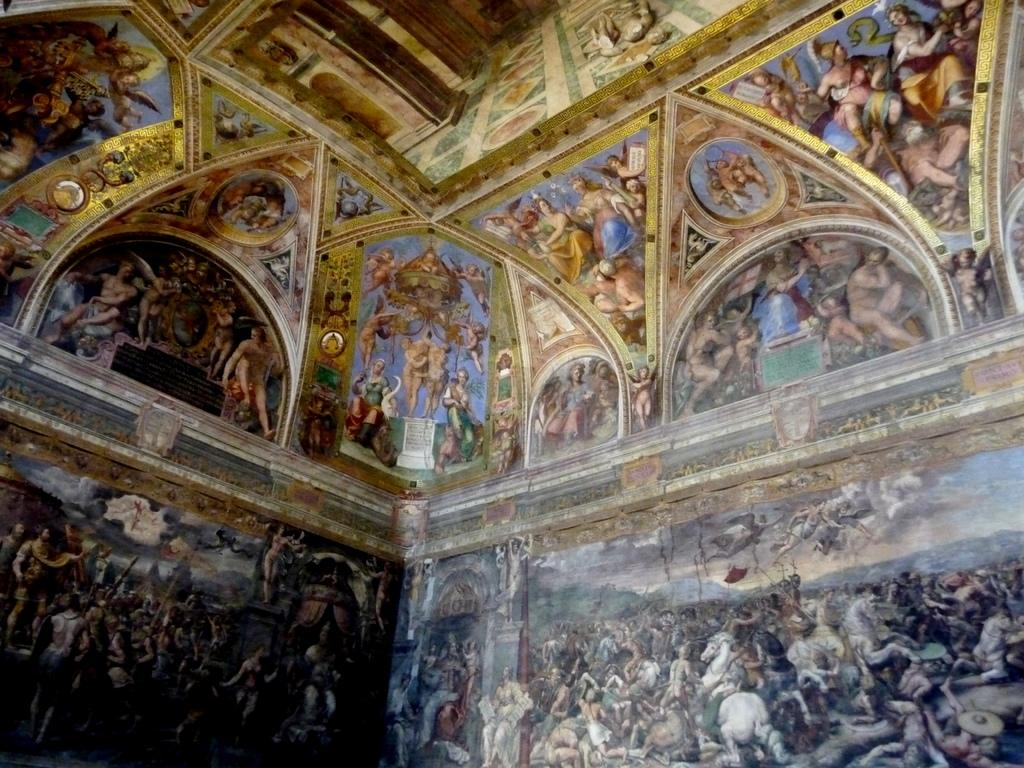What type of view does the image provide? The image provides an inside view of a room. What can be seen on the walls of the room? There is a group of paintings engraved on the walls of the room. What direction is the toy facing in the image? There is no toy present in the image. Can you describe the shape of the ear in the image? There is no ear present in the image. 